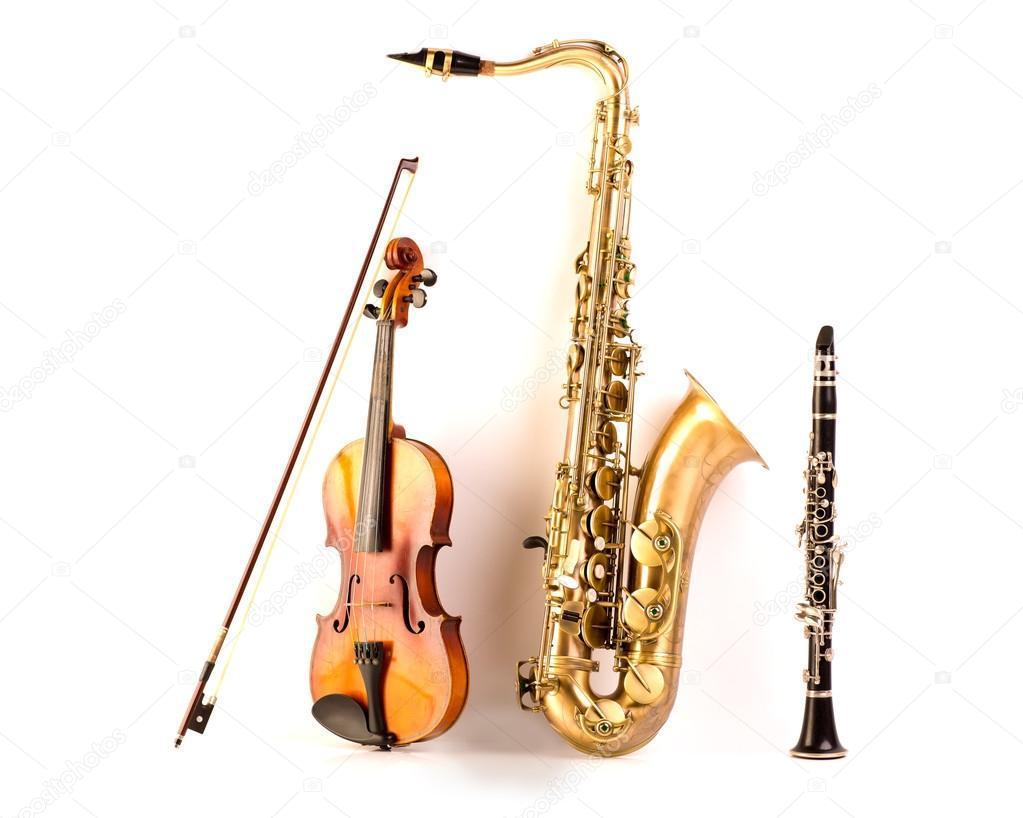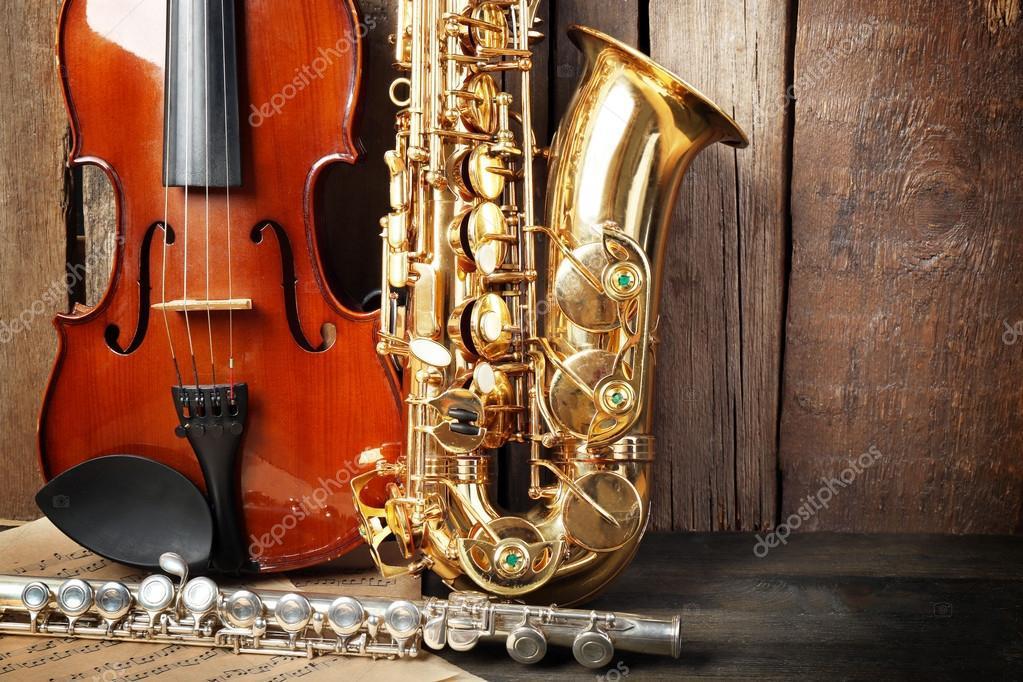The first image is the image on the left, the second image is the image on the right. Evaluate the accuracy of this statement regarding the images: "A violin is next to a saxophone in each image.". Is it true? Answer yes or no. Yes. The first image is the image on the left, the second image is the image on the right. Considering the images on both sides, is "Both images contain three instruments." valid? Answer yes or no. Yes. 